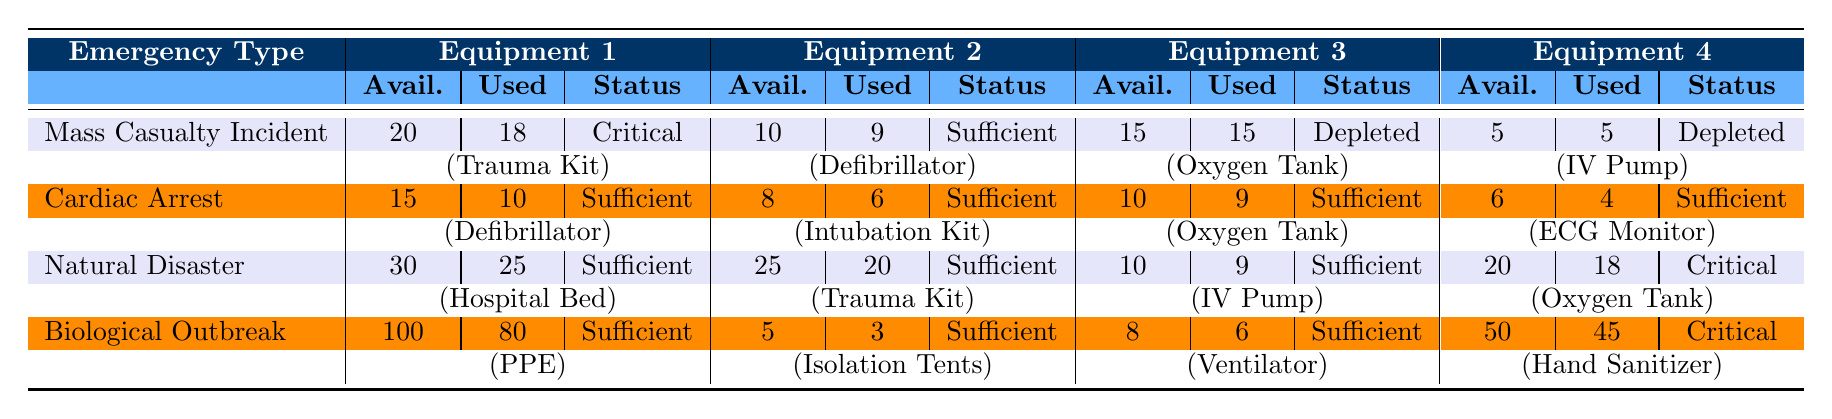What is the status of the Oxygen Tank during a Mass Casualty Incident? In the Mass Casualty Incident row, the Oxygen Tank has a status noted as "Depleted".
Answer: Depleted How many Trauma Kits are available for use during a Natural Disaster? The available count for Trauma Kits in the Natural Disaster row is 25.
Answer: 25 Is the number of available Ventilators sufficient for a Biological Outbreak? In the Biological Outbreak row, there are 8 Ventilators available, with the status listed as "Sufficient".
Answer: Yes What is the total number of Oxygen Tanks used across all emergency types? The total usage of Oxygen Tanks can be found by summing them up: 15 (Mass Casualty Incident) + 9 (Cardiac Arrest) + 18 (Natural Disaster) + 45 (Biological Outbreak) = 87.
Answer: 87 Which emergency type has the highest number of available Hospital Beds? Looking at the Hospital Bed values, the Natural Disaster category has 30 available Hospital Beds, which is the highest compared to other categories.
Answer: Natural Disaster For which emergency type is the status of Hand Sanitizer critical? The Hand Sanitizer status is "Critical" in the Biological Outbreak category.
Answer: Biological Outbreak How many more Trauma Kits were used in a Mass Casualty Incident compared to a Cardiac Arrest? The difference in usage of Trauma Kits is calculated by subtracting the number used in Cardiac Arrest (6) from Mass Casualty Incident (18): 18 - 6 = 12.
Answer: 12 Is there any equipment categorized as critical across all emergency types? The Oxygen Tank during a Mass Casualty Incident and the Hand Sanitizer during a Biological Outbreak are both marked as "Critical", indicating that there are indeed critical equipment.
Answer: Yes What is the ratio of available to used Defibrillators in a Cardiac Arrest? For Cardiac Arrest, there are 15 Defibrillators available and 10 used, giving a ratio of 15:10 which simplifies to 3:2.
Answer: 3:2 Which emergency type has the lowest available equipment status, and what is it? The lowest available equipment status occurred in the Mass Casualty Incident for both the Oxygen Tank and IV Pump, both classified as "Depleted". The status overall is "Critical".
Answer: Mass Casualty Incident, Critical 